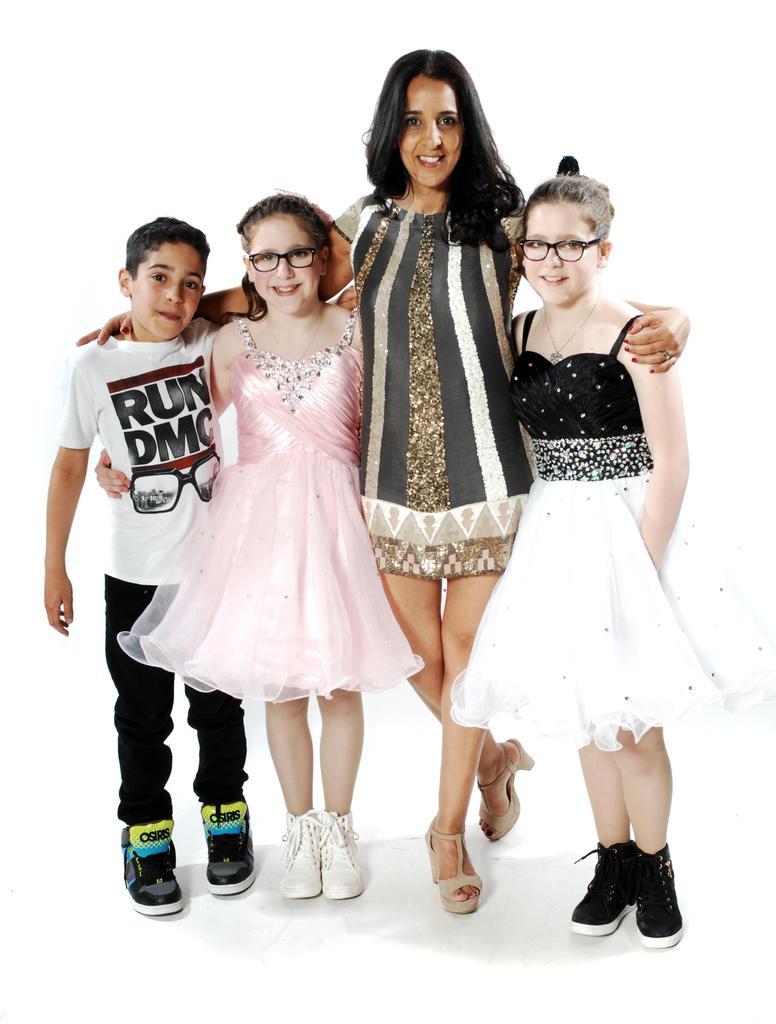Please provide a concise description of this image. In this image, we can see people standing and some are wearing glasses. At the bottom, there is a floor. 